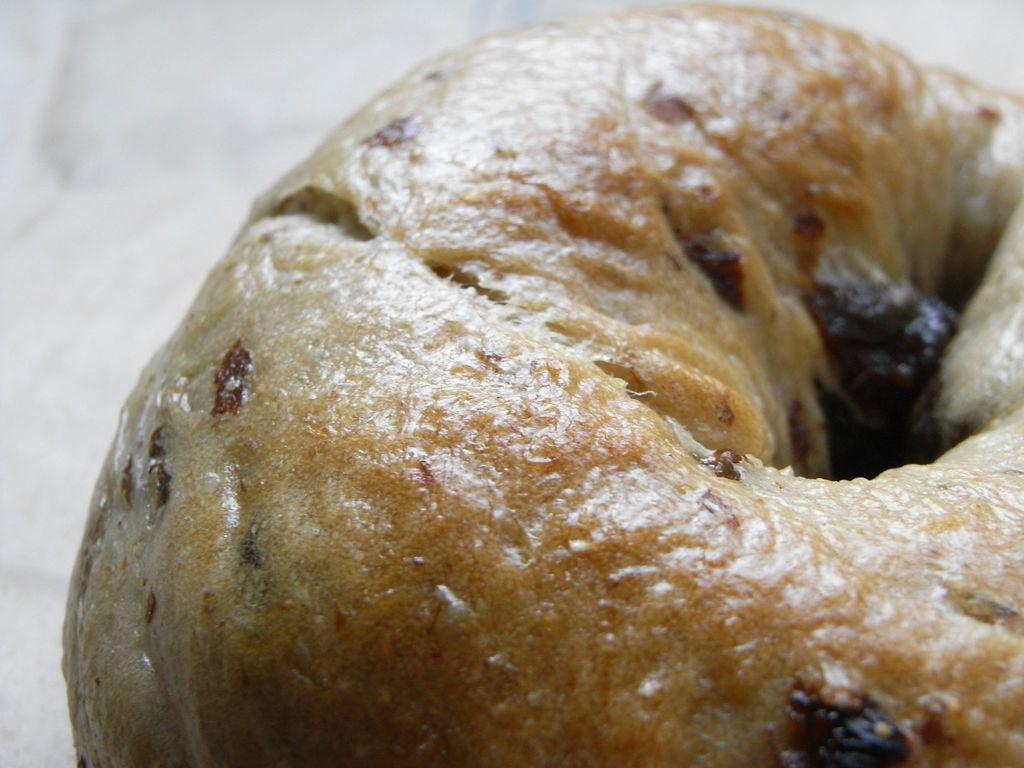What is the color of the surface in the image? The surface in the image is white colored. What is placed on the white colored surface? There is a food item on the white colored surface. What is the color of the food item? The food item is brown in color. How many bricks can be seen in the image? There are no bricks present in the image. What type of corn is being cooked on the range in the image? There is no range or corn present in the image. 